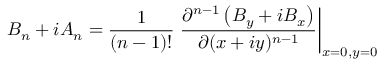Convert formula to latex. <formula><loc_0><loc_0><loc_500><loc_500>B _ { n } + i A _ { n } = \frac { 1 } { ( n - 1 ) ! } \frac { \partial ^ { n - 1 } \left ( B _ { y } + i B _ { x } \right ) } { \partial ( x + i y ) ^ { n - 1 } } \right | _ { x = 0 , y = 0 }</formula> 